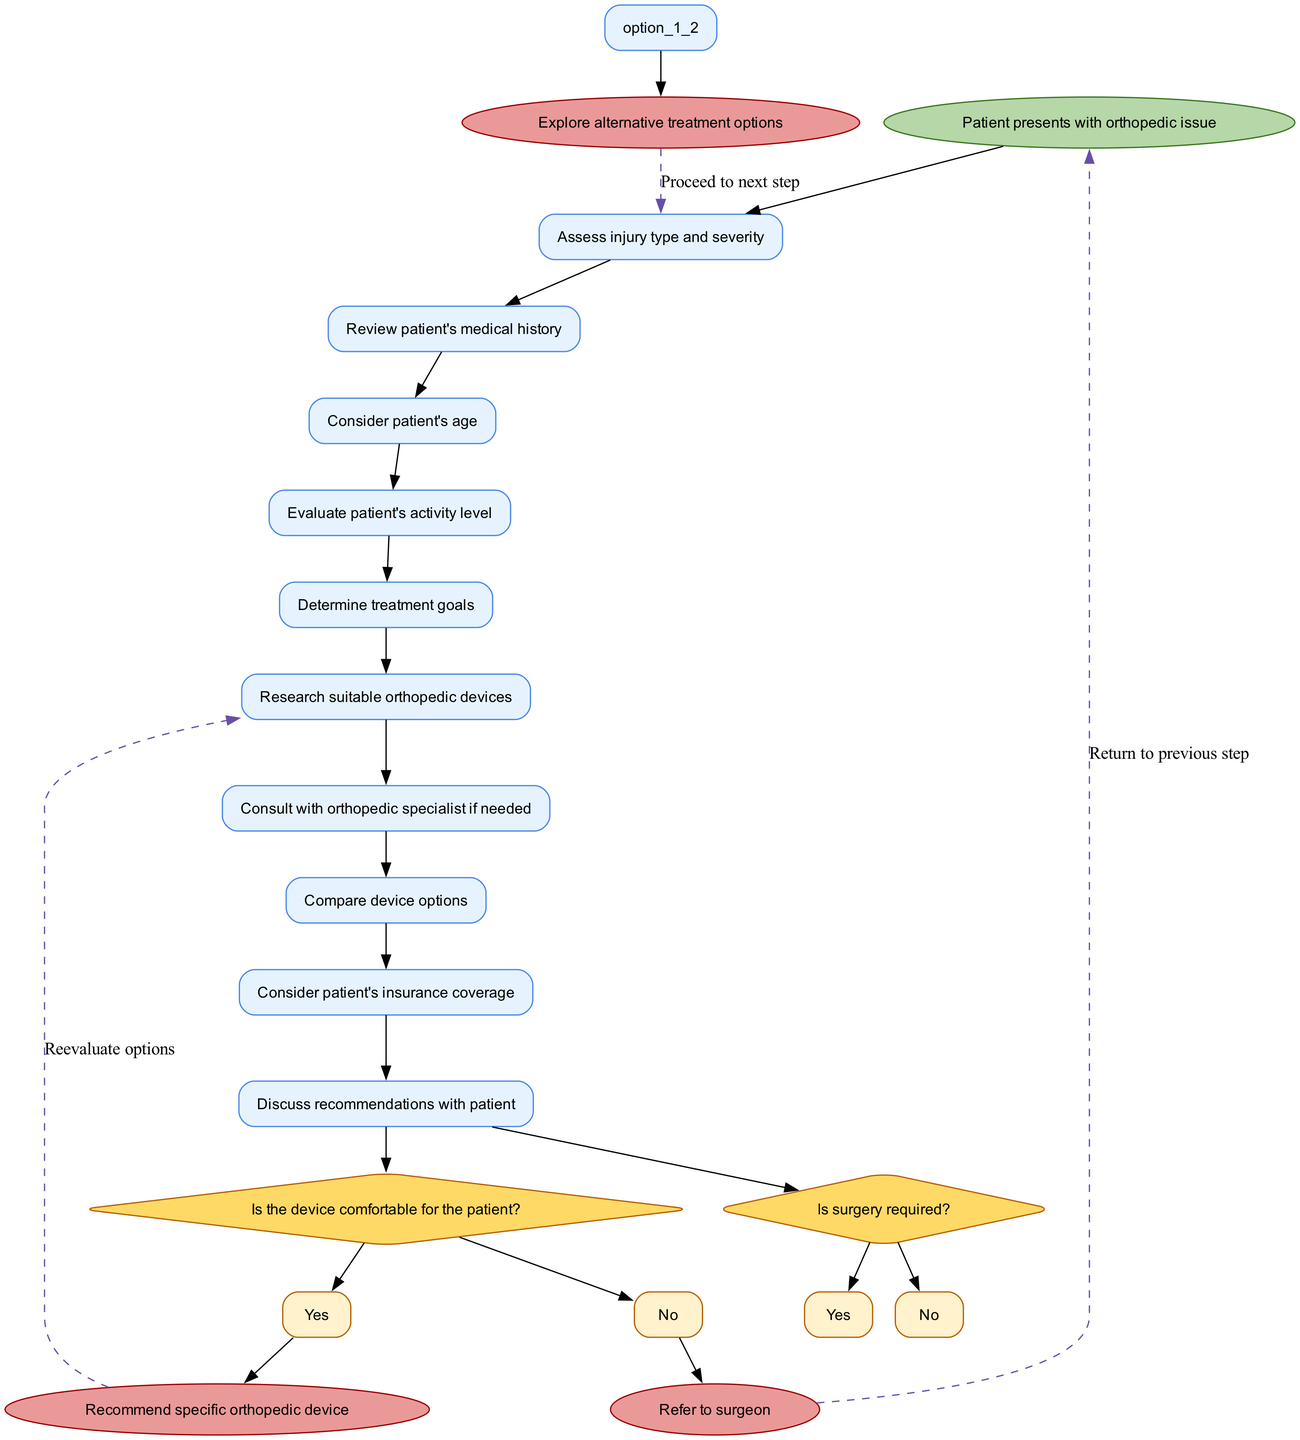What is the starting point of the decision-making process? The starting point, or start node, is indicated in the diagram as "Patient presents with orthopedic issue." This is the first node shown on the flow of the activity diagram.
Answer: Patient presents with orthopedic issue How many activity nodes are there in the diagram? The diagram contains a total of 10 activity nodes, which include steps like "Assess injury type and severity" and "Discuss recommendations with patient." I counted each unique activity listed in the activities section.
Answer: 10 What are the options provided in the first decision node? The first decision node asks, "Is surgery required?" The provided options in this decision are "Yes" and "No," as per the options specified for the first decision node.
Answer: Yes, No What does the flow do if the device is comfortable for the patient? If the answer to the question "Is the device comfortable for the patient?" is "Yes," the flow leads directly to the next step, which is "Recommend specific orthopedic device," as indicated by the edges connecting from that decision node.
Answer: Recommend specific orthopedic device How does the flow handle a recommendation to refer to a surgeon? If the decision to the question "Is surgery required?" is "Yes," the flow leads to the end node "Refer to surgeon." This indicates that if surgery is deemed necessary, the next step is to refer the patient for a surgical intervention.
Answer: Refer to surgeon What happens if the treatment goals change during the process? The diagram has a dashed edge from "Recommend specific orthopedic device" to "Research suitable orthopedic devices." This suggests that if treatment goals change, there is an option to return and explore different devices based on the new goals.
Answer: Explore alternative treatment options What is the purpose of evaluating the patient's activity level? Evaluating the patient's activity level helps determine which orthopedic device would be most appropriate for them, integrating their lifestyle and ensuring that the recommended device supports their level of activity. This evaluation is vital to tailor the treatment effectively.
Answer: To determine suitable device What is a unique characteristic of an activity diagram? A key characteristic of an activity diagram is that it represents the workflow of decision-making processes with nodes and edges, indicating the flow of activities, outcomes of decisions, and how different elements are interconnected in the overall process.
Answer: Represents workflow 